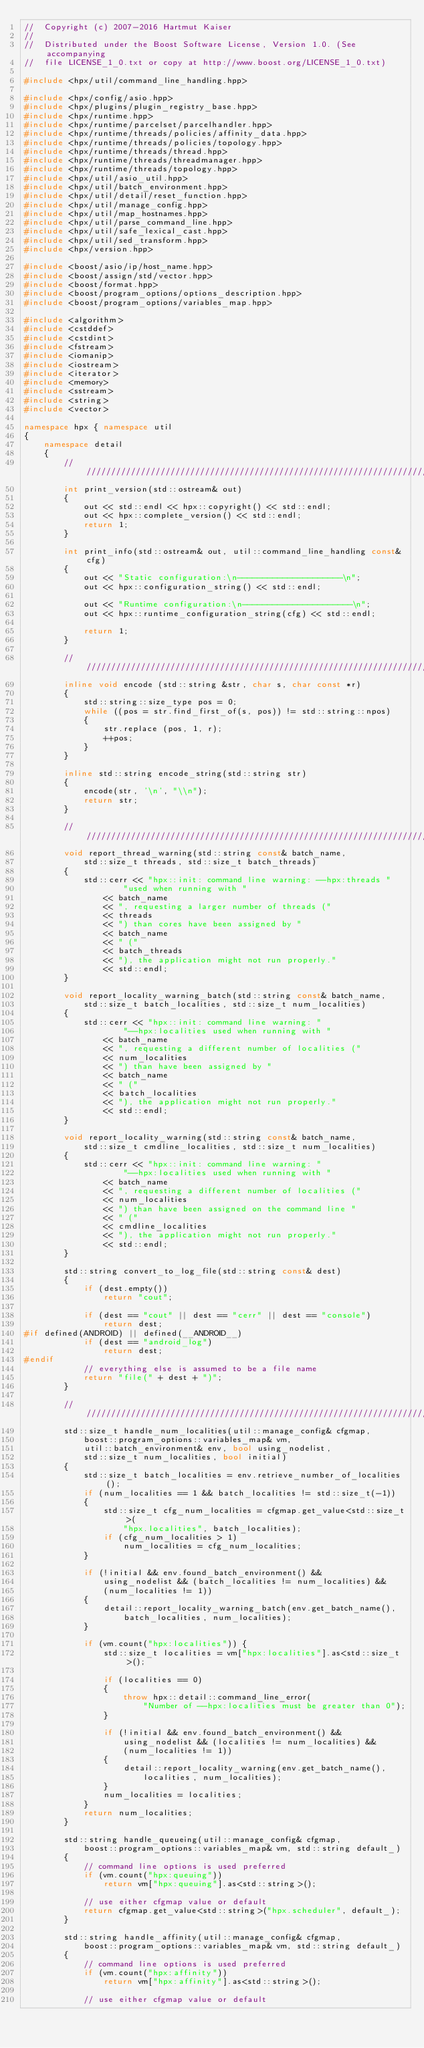<code> <loc_0><loc_0><loc_500><loc_500><_C++_>//  Copyright (c) 2007-2016 Hartmut Kaiser
//
//  Distributed under the Boost Software License, Version 1.0. (See accompanying
//  file LICENSE_1_0.txt or copy at http://www.boost.org/LICENSE_1_0.txt)

#include <hpx/util/command_line_handling.hpp>

#include <hpx/config/asio.hpp>
#include <hpx/plugins/plugin_registry_base.hpp>
#include <hpx/runtime.hpp>
#include <hpx/runtime/parcelset/parcelhandler.hpp>
#include <hpx/runtime/threads/policies/affinity_data.hpp>
#include <hpx/runtime/threads/policies/topology.hpp>
#include <hpx/runtime/threads/thread.hpp>
#include <hpx/runtime/threads/threadmanager.hpp>
#include <hpx/runtime/threads/topology.hpp>
#include <hpx/util/asio_util.hpp>
#include <hpx/util/batch_environment.hpp>
#include <hpx/util/detail/reset_function.hpp>
#include <hpx/util/manage_config.hpp>
#include <hpx/util/map_hostnames.hpp>
#include <hpx/util/parse_command_line.hpp>
#include <hpx/util/safe_lexical_cast.hpp>
#include <hpx/util/sed_transform.hpp>
#include <hpx/version.hpp>

#include <boost/asio/ip/host_name.hpp>
#include <boost/assign/std/vector.hpp>
#include <boost/format.hpp>
#include <boost/program_options/options_description.hpp>
#include <boost/program_options/variables_map.hpp>

#include <algorithm>
#include <cstddef>
#include <cstdint>
#include <fstream>
#include <iomanip>
#include <iostream>
#include <iterator>
#include <memory>
#include <sstream>
#include <string>
#include <vector>

namespace hpx { namespace util
{
    namespace detail
    {
        ///////////////////////////////////////////////////////////////////////
        int print_version(std::ostream& out)
        {
            out << std::endl << hpx::copyright() << std::endl;
            out << hpx::complete_version() << std::endl;
            return 1;
        }

        int print_info(std::ostream& out, util::command_line_handling const& cfg)
        {
            out << "Static configuration:\n---------------------\n";
            out << hpx::configuration_string() << std::endl;

            out << "Runtime configuration:\n----------------------\n";
            out << hpx::runtime_configuration_string(cfg) << std::endl;

            return 1;
        }

        ///////////////////////////////////////////////////////////////////////
        inline void encode (std::string &str, char s, char const *r)
        {
            std::string::size_type pos = 0;
            while ((pos = str.find_first_of(s, pos)) != std::string::npos)
            {
                str.replace (pos, 1, r);
                ++pos;
            }
        }

        inline std::string encode_string(std::string str)
        {
            encode(str, '\n', "\\n");
            return str;
        }

        ///////////////////////////////////////////////////////////////////////
        void report_thread_warning(std::string const& batch_name,
            std::size_t threads, std::size_t batch_threads)
        {
            std::cerr << "hpx::init: command line warning: --hpx:threads "
                    "used when running with "
                << batch_name
                << ", requesting a larger number of threads ("
                << threads
                << ") than cores have been assigned by "
                << batch_name
                << " ("
                << batch_threads
                << "), the application might not run properly."
                << std::endl;
        }

        void report_locality_warning_batch(std::string const& batch_name,
            std::size_t batch_localities, std::size_t num_localities)
        {
            std::cerr << "hpx::init: command line warning: "
                    "--hpx:localities used when running with "
                << batch_name
                << ", requesting a different number of localities ("
                << num_localities
                << ") than have been assigned by "
                << batch_name
                << " ("
                << batch_localities
                << "), the application might not run properly."
                << std::endl;
        }

        void report_locality_warning(std::string const& batch_name,
            std::size_t cmdline_localities, std::size_t num_localities)
        {
            std::cerr << "hpx::init: command line warning: "
                    "--hpx:localities used when running with "
                << batch_name
                << ", requesting a different number of localities ("
                << num_localities
                << ") than have been assigned on the command line "
                << " ("
                << cmdline_localities
                << "), the application might not run properly."
                << std::endl;
        }

        std::string convert_to_log_file(std::string const& dest)
        {
            if (dest.empty())
                return "cout";

            if (dest == "cout" || dest == "cerr" || dest == "console")
                return dest;
#if defined(ANDROID) || defined(__ANDROID__)
            if (dest == "android_log")
                return dest;
#endif
            // everything else is assumed to be a file name
            return "file(" + dest + ")";
        }

        ///////////////////////////////////////////////////////////////////////
        std::size_t handle_num_localities(util::manage_config& cfgmap,
            boost::program_options::variables_map& vm,
            util::batch_environment& env, bool using_nodelist,
            std::size_t num_localities, bool initial)
        {
            std::size_t batch_localities = env.retrieve_number_of_localities();
            if (num_localities == 1 && batch_localities != std::size_t(-1))
            {
                std::size_t cfg_num_localities = cfgmap.get_value<std::size_t>(
                    "hpx.localities", batch_localities);
                if (cfg_num_localities > 1)
                    num_localities = cfg_num_localities;
            }

            if (!initial && env.found_batch_environment() &&
                using_nodelist && (batch_localities != num_localities) &&
                (num_localities != 1))
            {
                detail::report_locality_warning_batch(env.get_batch_name(),
                    batch_localities, num_localities);
            }

            if (vm.count("hpx:localities")) {
                std::size_t localities = vm["hpx:localities"].as<std::size_t>();

                if (localities == 0)
                {
                    throw hpx::detail::command_line_error(
                        "Number of --hpx:localities must be greater than 0");
                }

                if (!initial && env.found_batch_environment() &&
                    using_nodelist && (localities != num_localities) &&
                    (num_localities != 1))
                {
                    detail::report_locality_warning(env.get_batch_name(),
                        localities, num_localities);
                }
                num_localities = localities;
            }
            return num_localities;
        }

        std::string handle_queueing(util::manage_config& cfgmap,
            boost::program_options::variables_map& vm, std::string default_)
        {
            // command line options is used preferred
            if (vm.count("hpx:queuing"))
                return vm["hpx:queuing"].as<std::string>();

            // use either cfgmap value or default
            return cfgmap.get_value<std::string>("hpx.scheduler", default_);
        }

        std::string handle_affinity(util::manage_config& cfgmap,
            boost::program_options::variables_map& vm, std::string default_)
        {
            // command line options is used preferred
            if (vm.count("hpx:affinity"))
                return vm["hpx:affinity"].as<std::string>();

            // use either cfgmap value or default</code> 